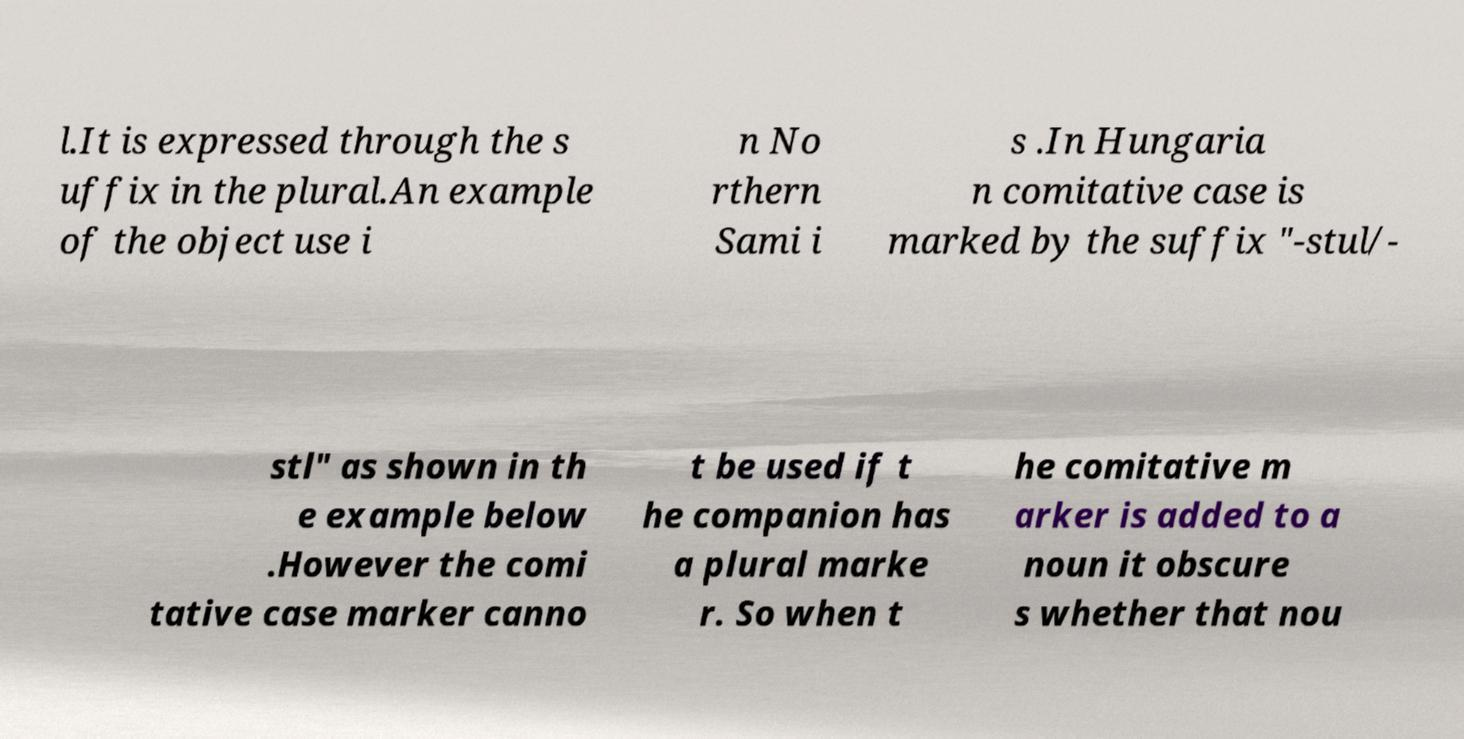What messages or text are displayed in this image? I need them in a readable, typed format. l.It is expressed through the s uffix in the plural.An example of the object use i n No rthern Sami i s .In Hungaria n comitative case is marked by the suffix "-stul/- stl" as shown in th e example below .However the comi tative case marker canno t be used if t he companion has a plural marke r. So when t he comitative m arker is added to a noun it obscure s whether that nou 